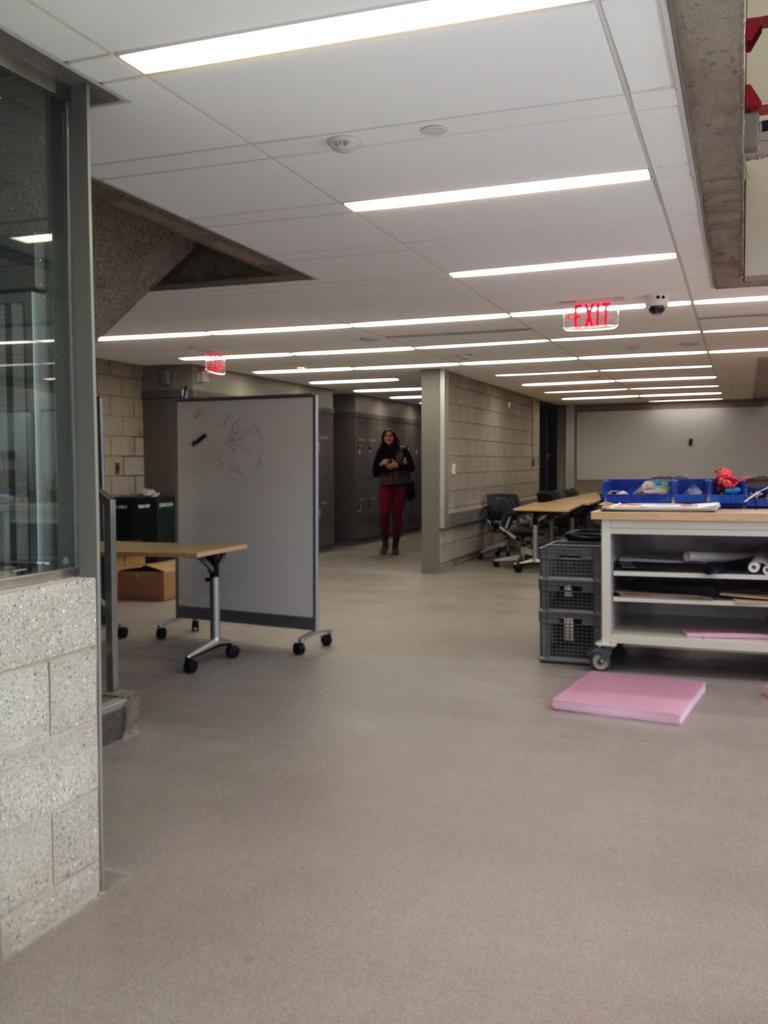In one or two sentences, can you explain what this image depicts? In this picture we can see a table. There are sign boards and some lights on top. We can see a few objects on the table on the right side. There are some chairs and a table at the back. We can see a glass on the right side. There is a woman and lockers in the background. 